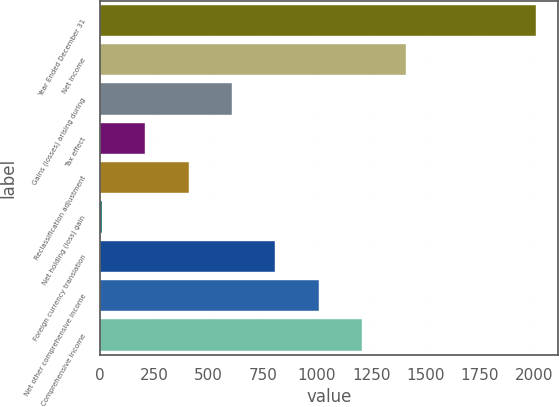Convert chart to OTSL. <chart><loc_0><loc_0><loc_500><loc_500><bar_chart><fcel>Year Ended December 31<fcel>Net income<fcel>Gains (losses) arising during<fcel>Tax effect<fcel>Reclassification adjustment<fcel>Net holding (loss) gain<fcel>Foreign currency translation<fcel>Net other comprehensive income<fcel>Comprehensive Income<nl><fcel>2011<fcel>1409.8<fcel>608.2<fcel>207.4<fcel>407.8<fcel>7<fcel>808.6<fcel>1009<fcel>1209.4<nl></chart> 